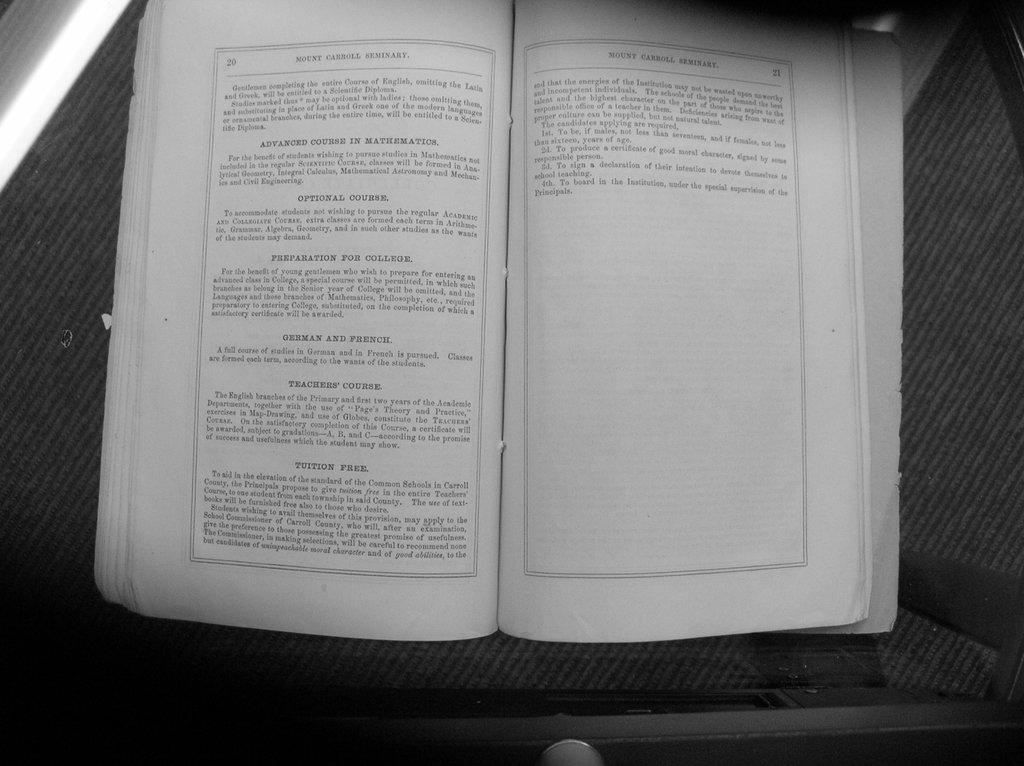<image>
Describe the image concisely. The Mount Carroll curriculum includes English and advanced mathematics. 